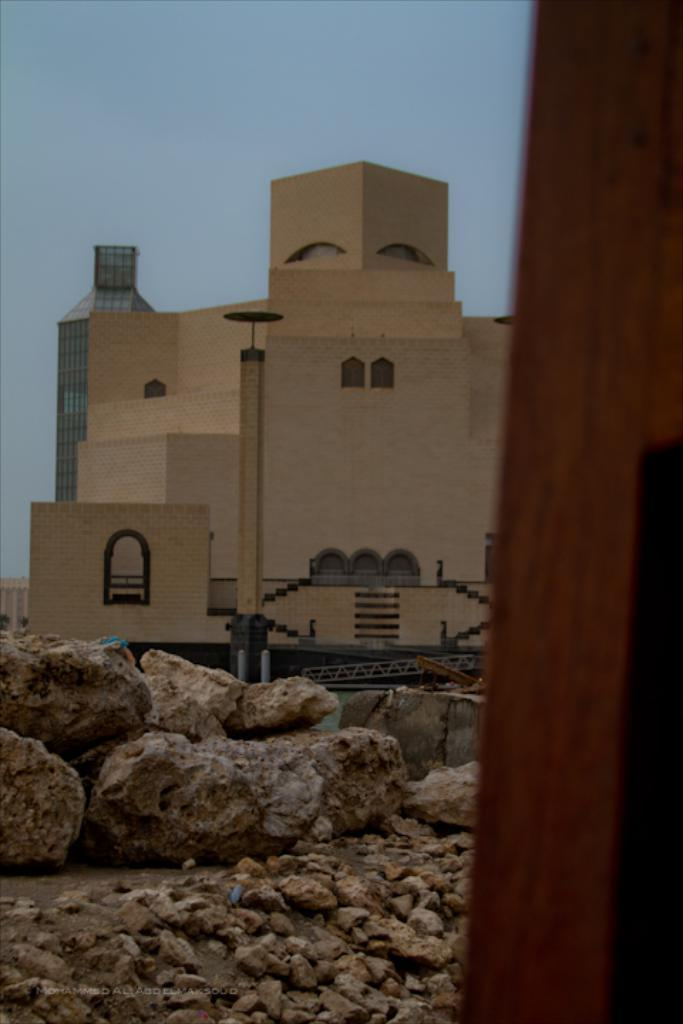What type of natural elements can be seen in the image? There are stones in the image. What type of man-made structures are present in the image? There are buildings and a tower in the image. What type of barrier can be seen in the image? There is a fence in the image. What type of wooden object is on the right side of the image? There is a wooden object on the right side of the image. What is visible in the sky in the image? The sky is visible in the image. Can you tell me how many cubs are playing with the eggnog in the image? There is no eggnog or cubs present in the image. What type of footwear is the person wearing in the image? There is no person or footwear visible in the image. 